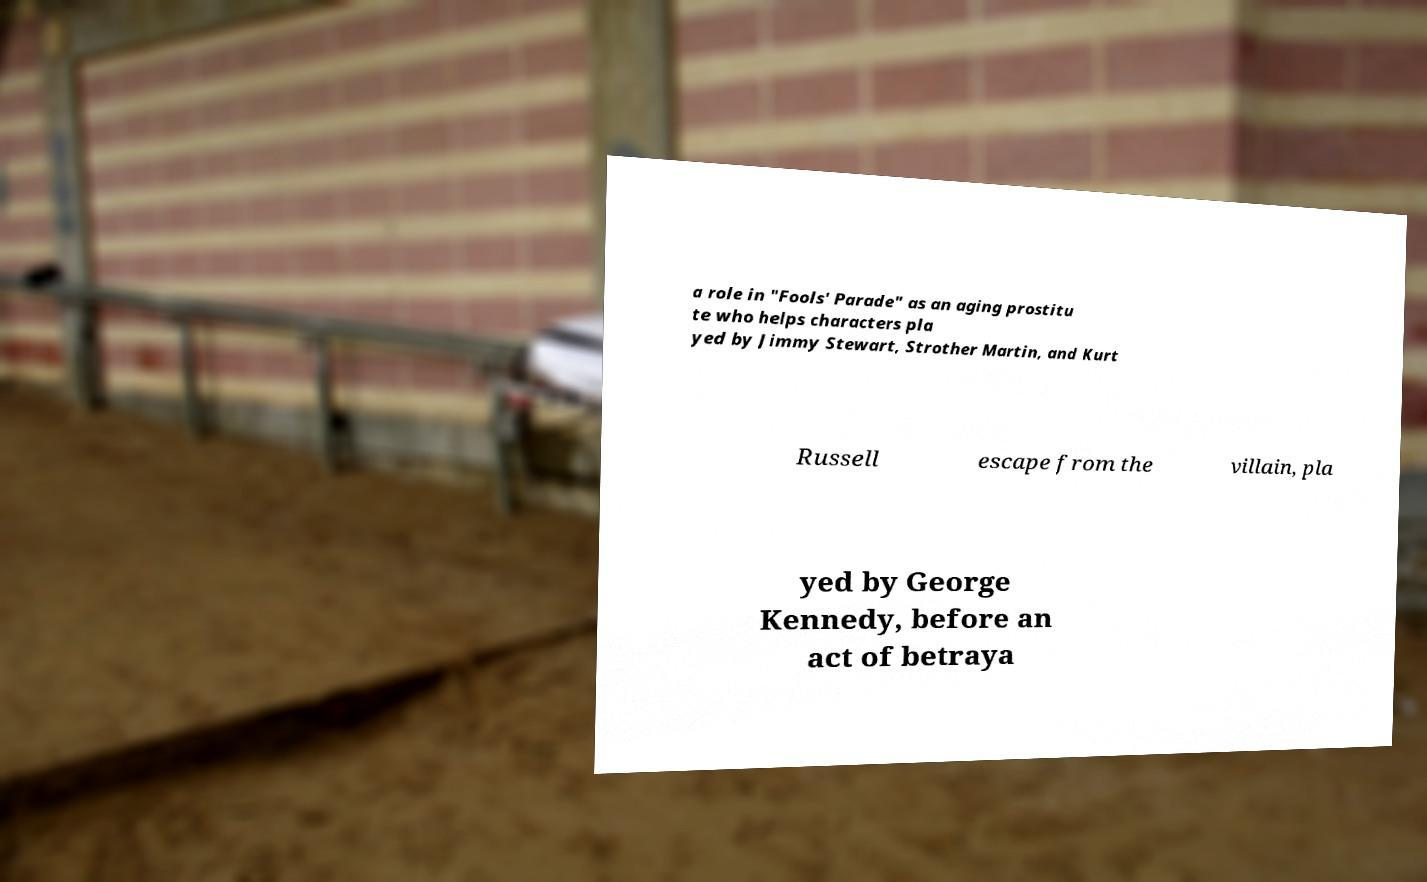Please identify and transcribe the text found in this image. a role in "Fools' Parade" as an aging prostitu te who helps characters pla yed by Jimmy Stewart, Strother Martin, and Kurt Russell escape from the villain, pla yed by George Kennedy, before an act of betraya 